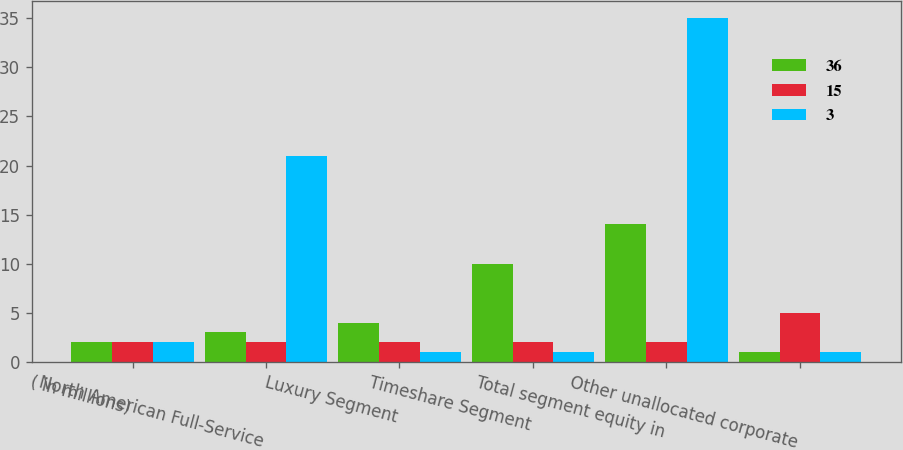Convert chart. <chart><loc_0><loc_0><loc_500><loc_500><stacked_bar_chart><ecel><fcel>( in millions)<fcel>North American Full-Service<fcel>Luxury Segment<fcel>Timeshare Segment<fcel>Total segment equity in<fcel>Other unallocated corporate<nl><fcel>36<fcel>2<fcel>3<fcel>4<fcel>10<fcel>14<fcel>1<nl><fcel>15<fcel>2<fcel>2<fcel>2<fcel>2<fcel>2<fcel>5<nl><fcel>3<fcel>2<fcel>21<fcel>1<fcel>1<fcel>35<fcel>1<nl></chart> 